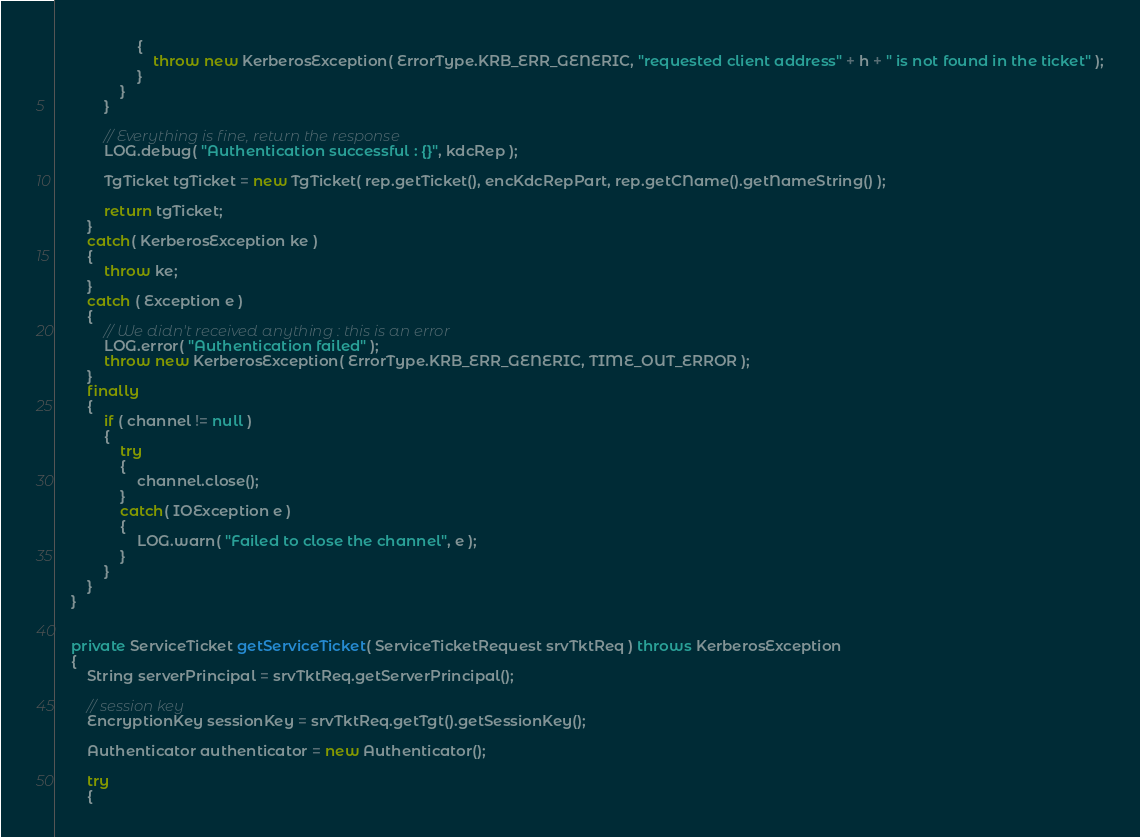Convert code to text. <code><loc_0><loc_0><loc_500><loc_500><_Java_>                    {
                        throw new KerberosException( ErrorType.KRB_ERR_GENERIC, "requested client address" + h + " is not found in the ticket" );
                    }
                }
            }
            
            // Everything is fine, return the response
            LOG.debug( "Authentication successful : {}", kdcRep );
            
            TgTicket tgTicket = new TgTicket( rep.getTicket(), encKdcRepPart, rep.getCName().getNameString() );
            
            return tgTicket;
        }
        catch( KerberosException ke )
        {
            throw ke;
        }
        catch ( Exception e )
        {
            // We didn't received anything : this is an error
            LOG.error( "Authentication failed" );
            throw new KerberosException( ErrorType.KRB_ERR_GENERIC, TIME_OUT_ERROR );
        }
        finally
        {
            if ( channel != null )
            {
                try
                {
                    channel.close();
                }
                catch( IOException e )
                {
                    LOG.warn( "Failed to close the channel", e );
                }
            }
        }
    }

    
    private ServiceTicket getServiceTicket( ServiceTicketRequest srvTktReq ) throws KerberosException
    {
        String serverPrincipal = srvTktReq.getServerPrincipal();
        
        // session key
        EncryptionKey sessionKey = srvTktReq.getTgt().getSessionKey();
        
        Authenticator authenticator = new Authenticator();
        
        try
        {</code> 